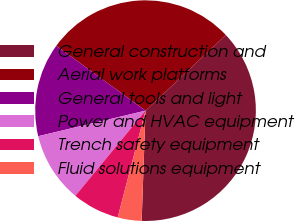Convert chart to OTSL. <chart><loc_0><loc_0><loc_500><loc_500><pie_chart><fcel>General construction and<fcel>Aerial work platforms<fcel>General tools and light<fcel>Power and HVAC equipment<fcel>Trench safety equipment<fcel>Fluid solutions equipment<nl><fcel>37.59%<fcel>27.97%<fcel>13.72%<fcel>10.31%<fcel>6.91%<fcel>3.5%<nl></chart> 